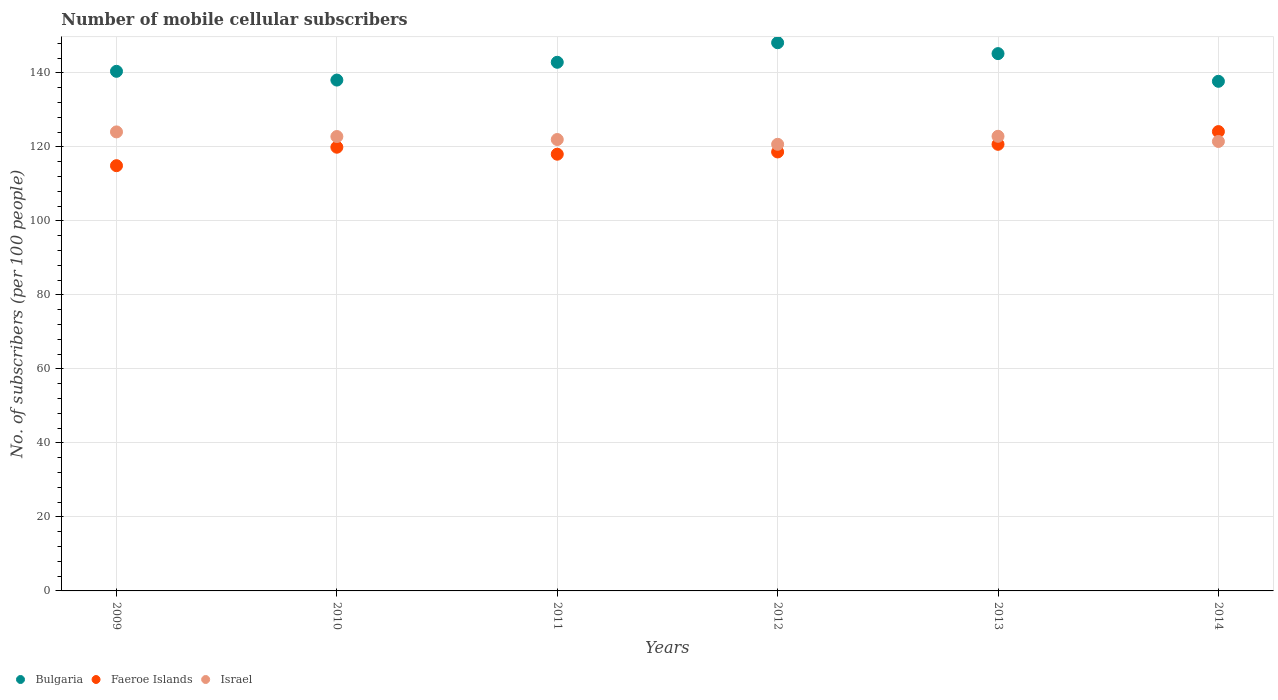How many different coloured dotlines are there?
Make the answer very short. 3. Is the number of dotlines equal to the number of legend labels?
Your answer should be compact. Yes. What is the number of mobile cellular subscribers in Faeroe Islands in 2012?
Your answer should be very brief. 118.62. Across all years, what is the maximum number of mobile cellular subscribers in Bulgaria?
Offer a terse response. 148.13. Across all years, what is the minimum number of mobile cellular subscribers in Israel?
Your answer should be very brief. 120.68. What is the total number of mobile cellular subscribers in Israel in the graph?
Ensure brevity in your answer.  733.78. What is the difference between the number of mobile cellular subscribers in Bulgaria in 2011 and that in 2014?
Give a very brief answer. 5.14. What is the difference between the number of mobile cellular subscribers in Bulgaria in 2010 and the number of mobile cellular subscribers in Faeroe Islands in 2009?
Your answer should be compact. 23.13. What is the average number of mobile cellular subscribers in Bulgaria per year?
Make the answer very short. 142.05. In the year 2011, what is the difference between the number of mobile cellular subscribers in Israel and number of mobile cellular subscribers in Faeroe Islands?
Give a very brief answer. 3.97. What is the ratio of the number of mobile cellular subscribers in Israel in 2009 to that in 2014?
Make the answer very short. 1.02. Is the number of mobile cellular subscribers in Bulgaria in 2013 less than that in 2014?
Provide a succinct answer. No. What is the difference between the highest and the second highest number of mobile cellular subscribers in Bulgaria?
Your answer should be very brief. 2.94. What is the difference between the highest and the lowest number of mobile cellular subscribers in Faeroe Islands?
Give a very brief answer. 9.21. In how many years, is the number of mobile cellular subscribers in Faeroe Islands greater than the average number of mobile cellular subscribers in Faeroe Islands taken over all years?
Offer a very short reply. 3. Is it the case that in every year, the sum of the number of mobile cellular subscribers in Israel and number of mobile cellular subscribers in Bulgaria  is greater than the number of mobile cellular subscribers in Faeroe Islands?
Your answer should be compact. Yes. Does the number of mobile cellular subscribers in Bulgaria monotonically increase over the years?
Ensure brevity in your answer.  No. Is the number of mobile cellular subscribers in Bulgaria strictly less than the number of mobile cellular subscribers in Faeroe Islands over the years?
Keep it short and to the point. No. What is the difference between two consecutive major ticks on the Y-axis?
Your answer should be very brief. 20. Does the graph contain any zero values?
Your answer should be very brief. No. Where does the legend appear in the graph?
Keep it short and to the point. Bottom left. What is the title of the graph?
Your answer should be compact. Number of mobile cellular subscribers. What is the label or title of the Y-axis?
Your answer should be compact. No. of subscribers (per 100 people). What is the No. of subscribers (per 100 people) in Bulgaria in 2009?
Your response must be concise. 140.4. What is the No. of subscribers (per 100 people) of Faeroe Islands in 2009?
Your answer should be compact. 114.91. What is the No. of subscribers (per 100 people) in Israel in 2009?
Provide a short and direct response. 124.03. What is the No. of subscribers (per 100 people) in Bulgaria in 2010?
Your answer should be very brief. 138.04. What is the No. of subscribers (per 100 people) of Faeroe Islands in 2010?
Provide a short and direct response. 119.9. What is the No. of subscribers (per 100 people) in Israel in 2010?
Keep it short and to the point. 122.78. What is the No. of subscribers (per 100 people) in Bulgaria in 2011?
Provide a succinct answer. 142.85. What is the No. of subscribers (per 100 people) of Faeroe Islands in 2011?
Keep it short and to the point. 118.01. What is the No. of subscribers (per 100 people) in Israel in 2011?
Offer a terse response. 121.98. What is the No. of subscribers (per 100 people) in Bulgaria in 2012?
Provide a succinct answer. 148.13. What is the No. of subscribers (per 100 people) in Faeroe Islands in 2012?
Keep it short and to the point. 118.62. What is the No. of subscribers (per 100 people) of Israel in 2012?
Your answer should be very brief. 120.68. What is the No. of subscribers (per 100 people) of Bulgaria in 2013?
Provide a short and direct response. 145.19. What is the No. of subscribers (per 100 people) of Faeroe Islands in 2013?
Offer a terse response. 120.68. What is the No. of subscribers (per 100 people) of Israel in 2013?
Your answer should be compact. 122.85. What is the No. of subscribers (per 100 people) in Bulgaria in 2014?
Make the answer very short. 137.71. What is the No. of subscribers (per 100 people) of Faeroe Islands in 2014?
Offer a terse response. 124.12. What is the No. of subscribers (per 100 people) in Israel in 2014?
Offer a terse response. 121.45. Across all years, what is the maximum No. of subscribers (per 100 people) of Bulgaria?
Your answer should be very brief. 148.13. Across all years, what is the maximum No. of subscribers (per 100 people) of Faeroe Islands?
Provide a short and direct response. 124.12. Across all years, what is the maximum No. of subscribers (per 100 people) in Israel?
Provide a succinct answer. 124.03. Across all years, what is the minimum No. of subscribers (per 100 people) in Bulgaria?
Make the answer very short. 137.71. Across all years, what is the minimum No. of subscribers (per 100 people) of Faeroe Islands?
Ensure brevity in your answer.  114.91. Across all years, what is the minimum No. of subscribers (per 100 people) of Israel?
Offer a terse response. 120.68. What is the total No. of subscribers (per 100 people) of Bulgaria in the graph?
Keep it short and to the point. 852.32. What is the total No. of subscribers (per 100 people) of Faeroe Islands in the graph?
Make the answer very short. 716.23. What is the total No. of subscribers (per 100 people) of Israel in the graph?
Give a very brief answer. 733.78. What is the difference between the No. of subscribers (per 100 people) in Bulgaria in 2009 and that in 2010?
Provide a short and direct response. 2.37. What is the difference between the No. of subscribers (per 100 people) in Faeroe Islands in 2009 and that in 2010?
Provide a succinct answer. -4.99. What is the difference between the No. of subscribers (per 100 people) of Israel in 2009 and that in 2010?
Provide a succinct answer. 1.25. What is the difference between the No. of subscribers (per 100 people) of Bulgaria in 2009 and that in 2011?
Your answer should be very brief. -2.44. What is the difference between the No. of subscribers (per 100 people) of Faeroe Islands in 2009 and that in 2011?
Keep it short and to the point. -3.1. What is the difference between the No. of subscribers (per 100 people) of Israel in 2009 and that in 2011?
Your response must be concise. 2.06. What is the difference between the No. of subscribers (per 100 people) of Bulgaria in 2009 and that in 2012?
Make the answer very short. -7.73. What is the difference between the No. of subscribers (per 100 people) in Faeroe Islands in 2009 and that in 2012?
Offer a terse response. -3.71. What is the difference between the No. of subscribers (per 100 people) in Israel in 2009 and that in 2012?
Provide a succinct answer. 3.35. What is the difference between the No. of subscribers (per 100 people) of Bulgaria in 2009 and that in 2013?
Keep it short and to the point. -4.78. What is the difference between the No. of subscribers (per 100 people) in Faeroe Islands in 2009 and that in 2013?
Give a very brief answer. -5.78. What is the difference between the No. of subscribers (per 100 people) of Israel in 2009 and that in 2013?
Ensure brevity in your answer.  1.19. What is the difference between the No. of subscribers (per 100 people) of Bulgaria in 2009 and that in 2014?
Offer a very short reply. 2.7. What is the difference between the No. of subscribers (per 100 people) of Faeroe Islands in 2009 and that in 2014?
Keep it short and to the point. -9.21. What is the difference between the No. of subscribers (per 100 people) in Israel in 2009 and that in 2014?
Offer a terse response. 2.58. What is the difference between the No. of subscribers (per 100 people) in Bulgaria in 2010 and that in 2011?
Make the answer very short. -4.81. What is the difference between the No. of subscribers (per 100 people) of Faeroe Islands in 2010 and that in 2011?
Your answer should be very brief. 1.89. What is the difference between the No. of subscribers (per 100 people) of Israel in 2010 and that in 2011?
Ensure brevity in your answer.  0.81. What is the difference between the No. of subscribers (per 100 people) in Bulgaria in 2010 and that in 2012?
Provide a short and direct response. -10.09. What is the difference between the No. of subscribers (per 100 people) of Faeroe Islands in 2010 and that in 2012?
Give a very brief answer. 1.28. What is the difference between the No. of subscribers (per 100 people) in Israel in 2010 and that in 2012?
Keep it short and to the point. 2.1. What is the difference between the No. of subscribers (per 100 people) in Bulgaria in 2010 and that in 2013?
Your response must be concise. -7.15. What is the difference between the No. of subscribers (per 100 people) of Faeroe Islands in 2010 and that in 2013?
Your answer should be compact. -0.78. What is the difference between the No. of subscribers (per 100 people) of Israel in 2010 and that in 2013?
Make the answer very short. -0.06. What is the difference between the No. of subscribers (per 100 people) in Bulgaria in 2010 and that in 2014?
Your answer should be compact. 0.33. What is the difference between the No. of subscribers (per 100 people) of Faeroe Islands in 2010 and that in 2014?
Keep it short and to the point. -4.22. What is the difference between the No. of subscribers (per 100 people) in Israel in 2010 and that in 2014?
Give a very brief answer. 1.33. What is the difference between the No. of subscribers (per 100 people) of Bulgaria in 2011 and that in 2012?
Offer a terse response. -5.29. What is the difference between the No. of subscribers (per 100 people) in Faeroe Islands in 2011 and that in 2012?
Your response must be concise. -0.61. What is the difference between the No. of subscribers (per 100 people) of Israel in 2011 and that in 2012?
Make the answer very short. 1.29. What is the difference between the No. of subscribers (per 100 people) of Bulgaria in 2011 and that in 2013?
Keep it short and to the point. -2.34. What is the difference between the No. of subscribers (per 100 people) in Faeroe Islands in 2011 and that in 2013?
Your answer should be compact. -2.67. What is the difference between the No. of subscribers (per 100 people) of Israel in 2011 and that in 2013?
Your answer should be compact. -0.87. What is the difference between the No. of subscribers (per 100 people) in Bulgaria in 2011 and that in 2014?
Offer a terse response. 5.14. What is the difference between the No. of subscribers (per 100 people) of Faeroe Islands in 2011 and that in 2014?
Your response must be concise. -6.11. What is the difference between the No. of subscribers (per 100 people) of Israel in 2011 and that in 2014?
Your answer should be compact. 0.53. What is the difference between the No. of subscribers (per 100 people) of Bulgaria in 2012 and that in 2013?
Offer a very short reply. 2.94. What is the difference between the No. of subscribers (per 100 people) in Faeroe Islands in 2012 and that in 2013?
Offer a very short reply. -2.07. What is the difference between the No. of subscribers (per 100 people) of Israel in 2012 and that in 2013?
Offer a terse response. -2.16. What is the difference between the No. of subscribers (per 100 people) in Bulgaria in 2012 and that in 2014?
Your response must be concise. 10.42. What is the difference between the No. of subscribers (per 100 people) of Faeroe Islands in 2012 and that in 2014?
Your answer should be very brief. -5.5. What is the difference between the No. of subscribers (per 100 people) of Israel in 2012 and that in 2014?
Provide a short and direct response. -0.77. What is the difference between the No. of subscribers (per 100 people) in Bulgaria in 2013 and that in 2014?
Give a very brief answer. 7.48. What is the difference between the No. of subscribers (per 100 people) of Faeroe Islands in 2013 and that in 2014?
Ensure brevity in your answer.  -3.43. What is the difference between the No. of subscribers (per 100 people) of Israel in 2013 and that in 2014?
Give a very brief answer. 1.4. What is the difference between the No. of subscribers (per 100 people) of Bulgaria in 2009 and the No. of subscribers (per 100 people) of Faeroe Islands in 2010?
Your answer should be compact. 20.51. What is the difference between the No. of subscribers (per 100 people) of Bulgaria in 2009 and the No. of subscribers (per 100 people) of Israel in 2010?
Ensure brevity in your answer.  17.62. What is the difference between the No. of subscribers (per 100 people) in Faeroe Islands in 2009 and the No. of subscribers (per 100 people) in Israel in 2010?
Your response must be concise. -7.88. What is the difference between the No. of subscribers (per 100 people) in Bulgaria in 2009 and the No. of subscribers (per 100 people) in Faeroe Islands in 2011?
Your answer should be compact. 22.4. What is the difference between the No. of subscribers (per 100 people) in Bulgaria in 2009 and the No. of subscribers (per 100 people) in Israel in 2011?
Make the answer very short. 18.43. What is the difference between the No. of subscribers (per 100 people) in Faeroe Islands in 2009 and the No. of subscribers (per 100 people) in Israel in 2011?
Provide a short and direct response. -7.07. What is the difference between the No. of subscribers (per 100 people) of Bulgaria in 2009 and the No. of subscribers (per 100 people) of Faeroe Islands in 2012?
Make the answer very short. 21.79. What is the difference between the No. of subscribers (per 100 people) in Bulgaria in 2009 and the No. of subscribers (per 100 people) in Israel in 2012?
Give a very brief answer. 19.72. What is the difference between the No. of subscribers (per 100 people) of Faeroe Islands in 2009 and the No. of subscribers (per 100 people) of Israel in 2012?
Give a very brief answer. -5.78. What is the difference between the No. of subscribers (per 100 people) of Bulgaria in 2009 and the No. of subscribers (per 100 people) of Faeroe Islands in 2013?
Offer a terse response. 19.72. What is the difference between the No. of subscribers (per 100 people) of Bulgaria in 2009 and the No. of subscribers (per 100 people) of Israel in 2013?
Your answer should be compact. 17.56. What is the difference between the No. of subscribers (per 100 people) of Faeroe Islands in 2009 and the No. of subscribers (per 100 people) of Israel in 2013?
Your response must be concise. -7.94. What is the difference between the No. of subscribers (per 100 people) of Bulgaria in 2009 and the No. of subscribers (per 100 people) of Faeroe Islands in 2014?
Make the answer very short. 16.29. What is the difference between the No. of subscribers (per 100 people) of Bulgaria in 2009 and the No. of subscribers (per 100 people) of Israel in 2014?
Offer a very short reply. 18.95. What is the difference between the No. of subscribers (per 100 people) of Faeroe Islands in 2009 and the No. of subscribers (per 100 people) of Israel in 2014?
Offer a terse response. -6.55. What is the difference between the No. of subscribers (per 100 people) of Bulgaria in 2010 and the No. of subscribers (per 100 people) of Faeroe Islands in 2011?
Your response must be concise. 20.03. What is the difference between the No. of subscribers (per 100 people) of Bulgaria in 2010 and the No. of subscribers (per 100 people) of Israel in 2011?
Give a very brief answer. 16.06. What is the difference between the No. of subscribers (per 100 people) of Faeroe Islands in 2010 and the No. of subscribers (per 100 people) of Israel in 2011?
Provide a succinct answer. -2.08. What is the difference between the No. of subscribers (per 100 people) of Bulgaria in 2010 and the No. of subscribers (per 100 people) of Faeroe Islands in 2012?
Your response must be concise. 19.42. What is the difference between the No. of subscribers (per 100 people) of Bulgaria in 2010 and the No. of subscribers (per 100 people) of Israel in 2012?
Ensure brevity in your answer.  17.35. What is the difference between the No. of subscribers (per 100 people) of Faeroe Islands in 2010 and the No. of subscribers (per 100 people) of Israel in 2012?
Your answer should be very brief. -0.79. What is the difference between the No. of subscribers (per 100 people) in Bulgaria in 2010 and the No. of subscribers (per 100 people) in Faeroe Islands in 2013?
Make the answer very short. 17.36. What is the difference between the No. of subscribers (per 100 people) in Bulgaria in 2010 and the No. of subscribers (per 100 people) in Israel in 2013?
Your answer should be compact. 15.19. What is the difference between the No. of subscribers (per 100 people) of Faeroe Islands in 2010 and the No. of subscribers (per 100 people) of Israel in 2013?
Provide a succinct answer. -2.95. What is the difference between the No. of subscribers (per 100 people) in Bulgaria in 2010 and the No. of subscribers (per 100 people) in Faeroe Islands in 2014?
Provide a short and direct response. 13.92. What is the difference between the No. of subscribers (per 100 people) in Bulgaria in 2010 and the No. of subscribers (per 100 people) in Israel in 2014?
Provide a short and direct response. 16.59. What is the difference between the No. of subscribers (per 100 people) of Faeroe Islands in 2010 and the No. of subscribers (per 100 people) of Israel in 2014?
Provide a short and direct response. -1.55. What is the difference between the No. of subscribers (per 100 people) of Bulgaria in 2011 and the No. of subscribers (per 100 people) of Faeroe Islands in 2012?
Ensure brevity in your answer.  24.23. What is the difference between the No. of subscribers (per 100 people) in Bulgaria in 2011 and the No. of subscribers (per 100 people) in Israel in 2012?
Your answer should be compact. 22.16. What is the difference between the No. of subscribers (per 100 people) in Faeroe Islands in 2011 and the No. of subscribers (per 100 people) in Israel in 2012?
Provide a short and direct response. -2.67. What is the difference between the No. of subscribers (per 100 people) in Bulgaria in 2011 and the No. of subscribers (per 100 people) in Faeroe Islands in 2013?
Your answer should be very brief. 22.16. What is the difference between the No. of subscribers (per 100 people) of Bulgaria in 2011 and the No. of subscribers (per 100 people) of Israel in 2013?
Make the answer very short. 20. What is the difference between the No. of subscribers (per 100 people) of Faeroe Islands in 2011 and the No. of subscribers (per 100 people) of Israel in 2013?
Make the answer very short. -4.84. What is the difference between the No. of subscribers (per 100 people) in Bulgaria in 2011 and the No. of subscribers (per 100 people) in Faeroe Islands in 2014?
Keep it short and to the point. 18.73. What is the difference between the No. of subscribers (per 100 people) in Bulgaria in 2011 and the No. of subscribers (per 100 people) in Israel in 2014?
Give a very brief answer. 21.4. What is the difference between the No. of subscribers (per 100 people) of Faeroe Islands in 2011 and the No. of subscribers (per 100 people) of Israel in 2014?
Your response must be concise. -3.44. What is the difference between the No. of subscribers (per 100 people) of Bulgaria in 2012 and the No. of subscribers (per 100 people) of Faeroe Islands in 2013?
Provide a succinct answer. 27.45. What is the difference between the No. of subscribers (per 100 people) of Bulgaria in 2012 and the No. of subscribers (per 100 people) of Israel in 2013?
Your response must be concise. 25.28. What is the difference between the No. of subscribers (per 100 people) in Faeroe Islands in 2012 and the No. of subscribers (per 100 people) in Israel in 2013?
Your response must be concise. -4.23. What is the difference between the No. of subscribers (per 100 people) in Bulgaria in 2012 and the No. of subscribers (per 100 people) in Faeroe Islands in 2014?
Offer a terse response. 24.01. What is the difference between the No. of subscribers (per 100 people) in Bulgaria in 2012 and the No. of subscribers (per 100 people) in Israel in 2014?
Your response must be concise. 26.68. What is the difference between the No. of subscribers (per 100 people) in Faeroe Islands in 2012 and the No. of subscribers (per 100 people) in Israel in 2014?
Provide a succinct answer. -2.83. What is the difference between the No. of subscribers (per 100 people) of Bulgaria in 2013 and the No. of subscribers (per 100 people) of Faeroe Islands in 2014?
Provide a short and direct response. 21.07. What is the difference between the No. of subscribers (per 100 people) of Bulgaria in 2013 and the No. of subscribers (per 100 people) of Israel in 2014?
Your answer should be very brief. 23.74. What is the difference between the No. of subscribers (per 100 people) of Faeroe Islands in 2013 and the No. of subscribers (per 100 people) of Israel in 2014?
Make the answer very short. -0.77. What is the average No. of subscribers (per 100 people) of Bulgaria per year?
Your answer should be compact. 142.05. What is the average No. of subscribers (per 100 people) in Faeroe Islands per year?
Your response must be concise. 119.37. What is the average No. of subscribers (per 100 people) of Israel per year?
Your response must be concise. 122.3. In the year 2009, what is the difference between the No. of subscribers (per 100 people) in Bulgaria and No. of subscribers (per 100 people) in Faeroe Islands?
Ensure brevity in your answer.  25.5. In the year 2009, what is the difference between the No. of subscribers (per 100 people) in Bulgaria and No. of subscribers (per 100 people) in Israel?
Make the answer very short. 16.37. In the year 2009, what is the difference between the No. of subscribers (per 100 people) in Faeroe Islands and No. of subscribers (per 100 people) in Israel?
Provide a succinct answer. -9.13. In the year 2010, what is the difference between the No. of subscribers (per 100 people) of Bulgaria and No. of subscribers (per 100 people) of Faeroe Islands?
Keep it short and to the point. 18.14. In the year 2010, what is the difference between the No. of subscribers (per 100 people) of Bulgaria and No. of subscribers (per 100 people) of Israel?
Give a very brief answer. 15.26. In the year 2010, what is the difference between the No. of subscribers (per 100 people) of Faeroe Islands and No. of subscribers (per 100 people) of Israel?
Give a very brief answer. -2.89. In the year 2011, what is the difference between the No. of subscribers (per 100 people) of Bulgaria and No. of subscribers (per 100 people) of Faeroe Islands?
Make the answer very short. 24.84. In the year 2011, what is the difference between the No. of subscribers (per 100 people) of Bulgaria and No. of subscribers (per 100 people) of Israel?
Ensure brevity in your answer.  20.87. In the year 2011, what is the difference between the No. of subscribers (per 100 people) of Faeroe Islands and No. of subscribers (per 100 people) of Israel?
Give a very brief answer. -3.97. In the year 2012, what is the difference between the No. of subscribers (per 100 people) of Bulgaria and No. of subscribers (per 100 people) of Faeroe Islands?
Offer a terse response. 29.52. In the year 2012, what is the difference between the No. of subscribers (per 100 people) of Bulgaria and No. of subscribers (per 100 people) of Israel?
Provide a short and direct response. 27.45. In the year 2012, what is the difference between the No. of subscribers (per 100 people) of Faeroe Islands and No. of subscribers (per 100 people) of Israel?
Your answer should be very brief. -2.07. In the year 2013, what is the difference between the No. of subscribers (per 100 people) in Bulgaria and No. of subscribers (per 100 people) in Faeroe Islands?
Your response must be concise. 24.51. In the year 2013, what is the difference between the No. of subscribers (per 100 people) of Bulgaria and No. of subscribers (per 100 people) of Israel?
Offer a terse response. 22.34. In the year 2013, what is the difference between the No. of subscribers (per 100 people) of Faeroe Islands and No. of subscribers (per 100 people) of Israel?
Provide a short and direct response. -2.17. In the year 2014, what is the difference between the No. of subscribers (per 100 people) of Bulgaria and No. of subscribers (per 100 people) of Faeroe Islands?
Ensure brevity in your answer.  13.59. In the year 2014, what is the difference between the No. of subscribers (per 100 people) in Bulgaria and No. of subscribers (per 100 people) in Israel?
Your response must be concise. 16.26. In the year 2014, what is the difference between the No. of subscribers (per 100 people) in Faeroe Islands and No. of subscribers (per 100 people) in Israel?
Make the answer very short. 2.67. What is the ratio of the No. of subscribers (per 100 people) in Bulgaria in 2009 to that in 2010?
Offer a terse response. 1.02. What is the ratio of the No. of subscribers (per 100 people) of Faeroe Islands in 2009 to that in 2010?
Offer a very short reply. 0.96. What is the ratio of the No. of subscribers (per 100 people) of Israel in 2009 to that in 2010?
Ensure brevity in your answer.  1.01. What is the ratio of the No. of subscribers (per 100 people) of Bulgaria in 2009 to that in 2011?
Give a very brief answer. 0.98. What is the ratio of the No. of subscribers (per 100 people) in Faeroe Islands in 2009 to that in 2011?
Make the answer very short. 0.97. What is the ratio of the No. of subscribers (per 100 people) of Israel in 2009 to that in 2011?
Provide a succinct answer. 1.02. What is the ratio of the No. of subscribers (per 100 people) in Bulgaria in 2009 to that in 2012?
Ensure brevity in your answer.  0.95. What is the ratio of the No. of subscribers (per 100 people) in Faeroe Islands in 2009 to that in 2012?
Ensure brevity in your answer.  0.97. What is the ratio of the No. of subscribers (per 100 people) of Israel in 2009 to that in 2012?
Your answer should be compact. 1.03. What is the ratio of the No. of subscribers (per 100 people) in Bulgaria in 2009 to that in 2013?
Make the answer very short. 0.97. What is the ratio of the No. of subscribers (per 100 people) in Faeroe Islands in 2009 to that in 2013?
Offer a very short reply. 0.95. What is the ratio of the No. of subscribers (per 100 people) in Israel in 2009 to that in 2013?
Offer a terse response. 1.01. What is the ratio of the No. of subscribers (per 100 people) of Bulgaria in 2009 to that in 2014?
Your answer should be very brief. 1.02. What is the ratio of the No. of subscribers (per 100 people) in Faeroe Islands in 2009 to that in 2014?
Ensure brevity in your answer.  0.93. What is the ratio of the No. of subscribers (per 100 people) in Israel in 2009 to that in 2014?
Your answer should be compact. 1.02. What is the ratio of the No. of subscribers (per 100 people) of Bulgaria in 2010 to that in 2011?
Your answer should be very brief. 0.97. What is the ratio of the No. of subscribers (per 100 people) in Faeroe Islands in 2010 to that in 2011?
Your answer should be compact. 1.02. What is the ratio of the No. of subscribers (per 100 people) in Israel in 2010 to that in 2011?
Offer a very short reply. 1.01. What is the ratio of the No. of subscribers (per 100 people) in Bulgaria in 2010 to that in 2012?
Provide a succinct answer. 0.93. What is the ratio of the No. of subscribers (per 100 people) in Faeroe Islands in 2010 to that in 2012?
Your answer should be very brief. 1.01. What is the ratio of the No. of subscribers (per 100 people) in Israel in 2010 to that in 2012?
Ensure brevity in your answer.  1.02. What is the ratio of the No. of subscribers (per 100 people) of Bulgaria in 2010 to that in 2013?
Your response must be concise. 0.95. What is the ratio of the No. of subscribers (per 100 people) in Bulgaria in 2010 to that in 2014?
Offer a terse response. 1. What is the ratio of the No. of subscribers (per 100 people) of Israel in 2010 to that in 2014?
Your answer should be very brief. 1.01. What is the ratio of the No. of subscribers (per 100 people) in Bulgaria in 2011 to that in 2012?
Provide a succinct answer. 0.96. What is the ratio of the No. of subscribers (per 100 people) of Israel in 2011 to that in 2012?
Provide a short and direct response. 1.01. What is the ratio of the No. of subscribers (per 100 people) of Bulgaria in 2011 to that in 2013?
Offer a very short reply. 0.98. What is the ratio of the No. of subscribers (per 100 people) of Faeroe Islands in 2011 to that in 2013?
Provide a succinct answer. 0.98. What is the ratio of the No. of subscribers (per 100 people) of Israel in 2011 to that in 2013?
Your answer should be very brief. 0.99. What is the ratio of the No. of subscribers (per 100 people) of Bulgaria in 2011 to that in 2014?
Ensure brevity in your answer.  1.04. What is the ratio of the No. of subscribers (per 100 people) in Faeroe Islands in 2011 to that in 2014?
Provide a short and direct response. 0.95. What is the ratio of the No. of subscribers (per 100 people) of Bulgaria in 2012 to that in 2013?
Offer a very short reply. 1.02. What is the ratio of the No. of subscribers (per 100 people) of Faeroe Islands in 2012 to that in 2013?
Your response must be concise. 0.98. What is the ratio of the No. of subscribers (per 100 people) of Israel in 2012 to that in 2013?
Offer a terse response. 0.98. What is the ratio of the No. of subscribers (per 100 people) in Bulgaria in 2012 to that in 2014?
Give a very brief answer. 1.08. What is the ratio of the No. of subscribers (per 100 people) in Faeroe Islands in 2012 to that in 2014?
Give a very brief answer. 0.96. What is the ratio of the No. of subscribers (per 100 people) of Bulgaria in 2013 to that in 2014?
Offer a very short reply. 1.05. What is the ratio of the No. of subscribers (per 100 people) of Faeroe Islands in 2013 to that in 2014?
Give a very brief answer. 0.97. What is the ratio of the No. of subscribers (per 100 people) in Israel in 2013 to that in 2014?
Provide a succinct answer. 1.01. What is the difference between the highest and the second highest No. of subscribers (per 100 people) of Bulgaria?
Your answer should be compact. 2.94. What is the difference between the highest and the second highest No. of subscribers (per 100 people) in Faeroe Islands?
Keep it short and to the point. 3.43. What is the difference between the highest and the second highest No. of subscribers (per 100 people) in Israel?
Offer a terse response. 1.19. What is the difference between the highest and the lowest No. of subscribers (per 100 people) of Bulgaria?
Ensure brevity in your answer.  10.42. What is the difference between the highest and the lowest No. of subscribers (per 100 people) in Faeroe Islands?
Keep it short and to the point. 9.21. What is the difference between the highest and the lowest No. of subscribers (per 100 people) in Israel?
Your answer should be very brief. 3.35. 